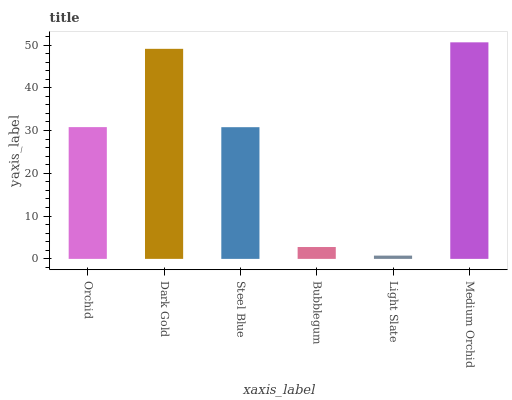Is Light Slate the minimum?
Answer yes or no. Yes. Is Medium Orchid the maximum?
Answer yes or no. Yes. Is Dark Gold the minimum?
Answer yes or no. No. Is Dark Gold the maximum?
Answer yes or no. No. Is Dark Gold greater than Orchid?
Answer yes or no. Yes. Is Orchid less than Dark Gold?
Answer yes or no. Yes. Is Orchid greater than Dark Gold?
Answer yes or no. No. Is Dark Gold less than Orchid?
Answer yes or no. No. Is Orchid the high median?
Answer yes or no. Yes. Is Steel Blue the low median?
Answer yes or no. Yes. Is Steel Blue the high median?
Answer yes or no. No. Is Orchid the low median?
Answer yes or no. No. 